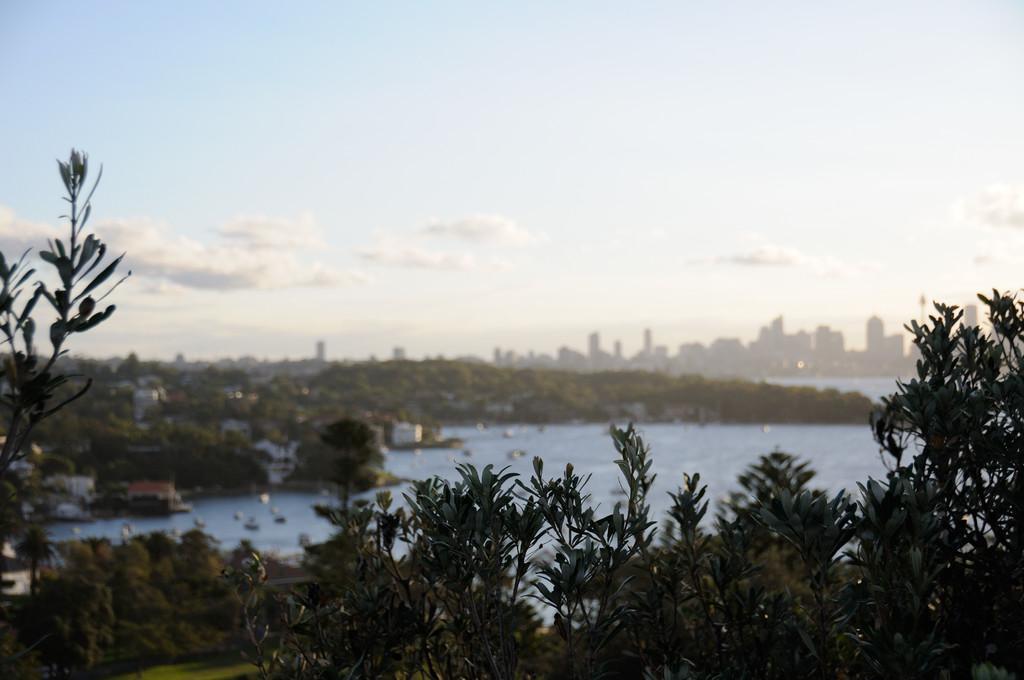Can you describe this image briefly? This is water. Here we can see plants, trees, and buildings. In the background there is sky. 